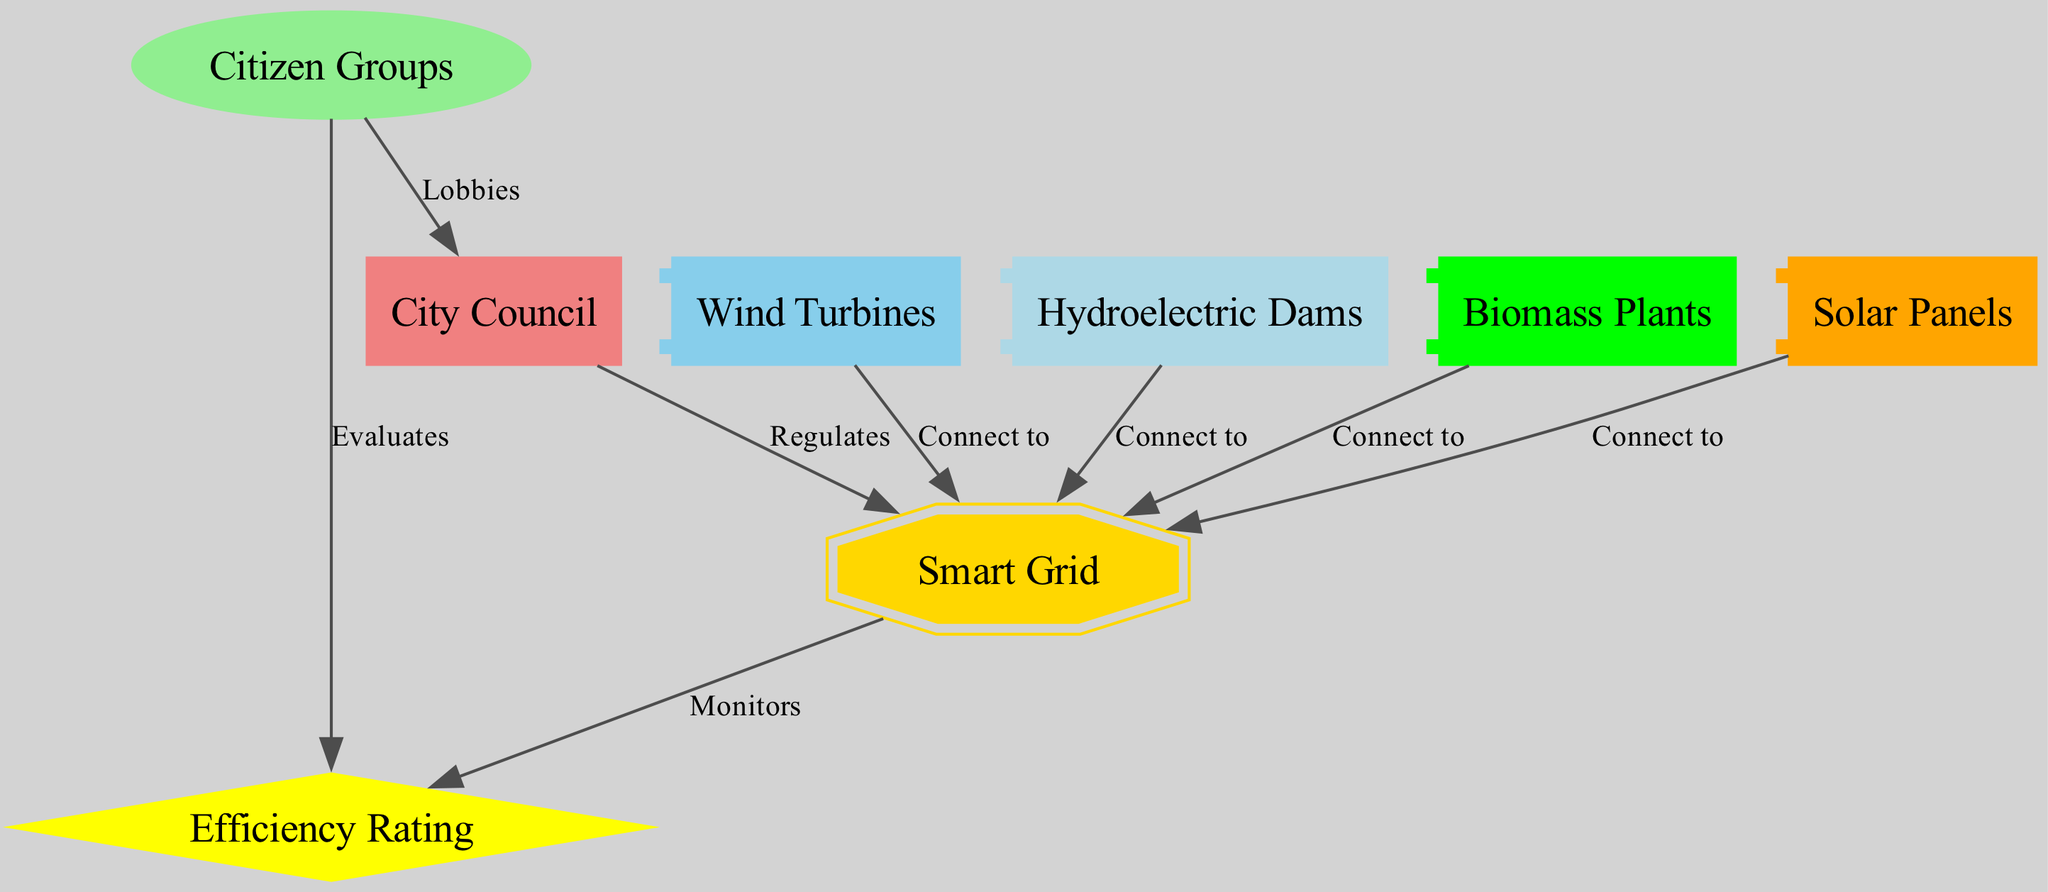What are the renewable energy sources represented in the diagram? The diagram lists solar panels, wind turbines, hydroelectric dams, and biomass plants as the renewable energy sources. Each of these is depicted as a node in the diagram, showing its significance to the overall system.
Answer: Solar panels, wind turbines, hydroelectric dams, biomass plants Which entity regulates the smart grid? The relationship indicates that the city council regulates the smart grid, as shown by the directed edge from the city council to the smart grid in the diagram. This signifies its oversight role in the energy management system.
Answer: City council How many renewable energy sources connect to the smart grid? There are four sources: solar panels, wind turbines, hydroelectric dams, and biomass plants. The diagram indicates these connections through edges leading from each energy source to the smart grid.
Answer: 4 What do citizen groups evaluate in the diagram? The directed edge from citizen groups to efficiency rating shows that they evaluate the efficiency of the smart grid and renewable energy sources. This is an important role in ensuring accountability and effectiveness.
Answer: Efficiency rating Which node monitors the efficiency rating? According to the diagram, the smart grid monitors the efficiency rating, as indicated by the edge from the smart grid to the efficiency rating node. This suggests that the smart grid plays an active role in tracking performance metrics.
Answer: Smart grid What shape is used to represent citizen groups? In the diagram, citizen groups are represented by an ellipse, distinct from other nodes. The shape is specifically chosen to signify the community aspect of this entity.
Answer: Ellipse What type of relationship exists between citizen groups and the city council? The citizen groups lobby the city council, as indicated by the directed edge connecting the two. This relationship shows the advocacy role that citizen groups play in local governance and utility regulation.
Answer: Lobbies Which renewable energy sources do not connect directly to the city council? The renewable energy sources—solar panels, wind turbines, hydroelectric dams, and biomass plants—do not connect directly to the city council; instead, they connect to the smart grid. This indicates that the council's interaction is mediated through the smart grid.
Answer: All renewable energy sources How is the efficiency rating determined? The efficiency rating is monitored by the smart grid and evaluated by citizen groups, as depicted in the diagram. So, it reflects a combination of technological oversight and community evaluation.
Answer: Monitored and evaluated 